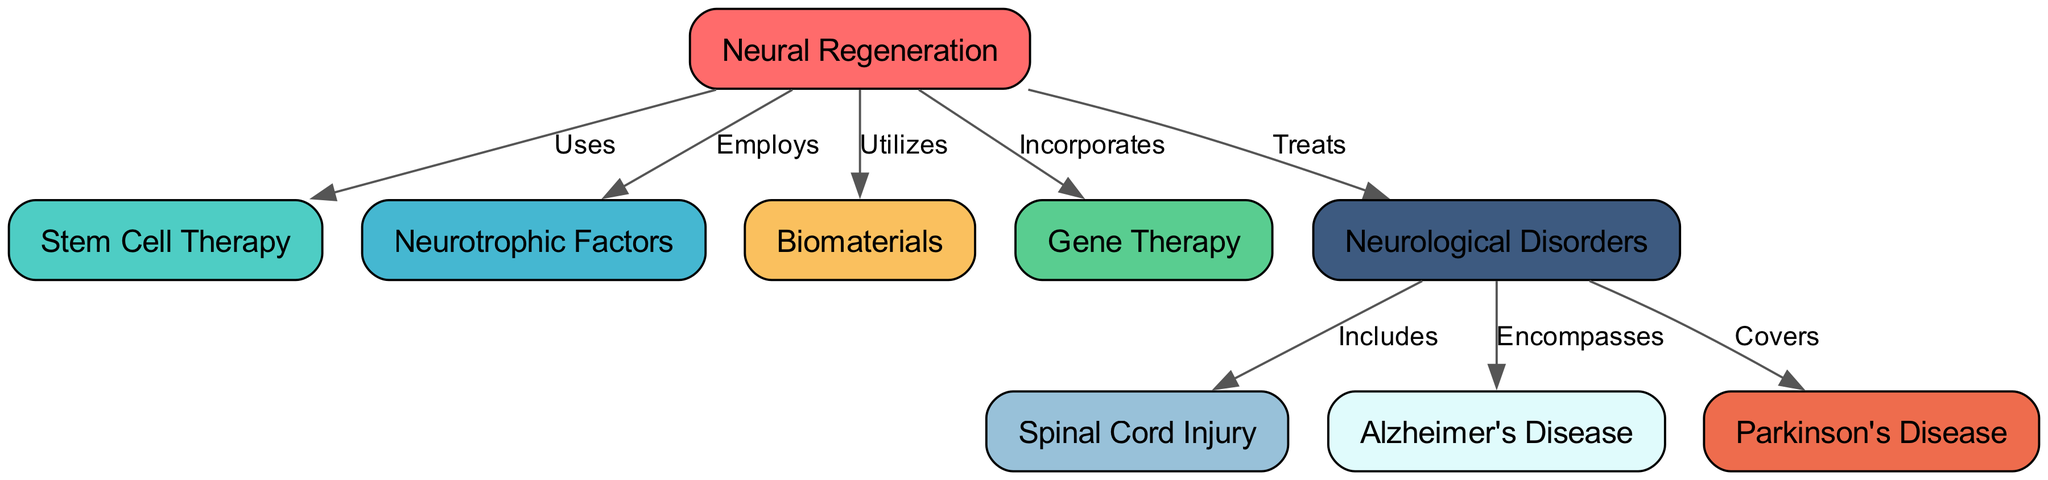What is the central theme of the diagram? The central theme of the diagram is "Neural Regeneration," which is the main node around which other elements are organized.
Answer: Neural Regeneration How many different techniques are used in neural regeneration? The diagram shows four techniques that are specifically linked to neural regeneration: stem cell therapy, neurotrophic factors, biomaterials, and gene therapy.
Answer: 4 Which neurological disorder is associated with spinal cord injury? The diagram indicates that spinal cord injury is included under the broader category of neurological disorders.
Answer: Spinal Cord Injury What type of therapy is linked to neurotrophic factors in the diagram? Neurotrophic factors are employed in the process of neural regeneration as indicated by the label connecting them to the central theme.
Answer: Employs What are the applications of stem cell therapy in the context of neural regeneration? The diagram shows that stem cell therapy is one of the techniques used to promote neural regeneration, making it relevant for treating neurological disorders.
Answer: Treats Which disorder is categorized under the umbrella of neurological disorders along with Alzheimer's disease? Parkinson's Disease is another neurological disorder mentioned in the diagram that is categorized alongside Alzheimer's Disease.
Answer: Parkinson's Disease How many edges connect the techniques used for neural regeneration to neurological disorders? The diagram illustrates a total of five edges linking the techniques to the different neurological disorders.
Answer: 5 What relationship does gene therapy have with neural regeneration? The diagram states that gene therapy incorporates strategies within the context of neural regeneration.
Answer: Incorporates How many neurological disorders are listed in the diagram? There are three neurological disorders mentioned in the diagram: spinal cord injury, Alzheimer's disease, and Parkinson's disease.
Answer: 3 